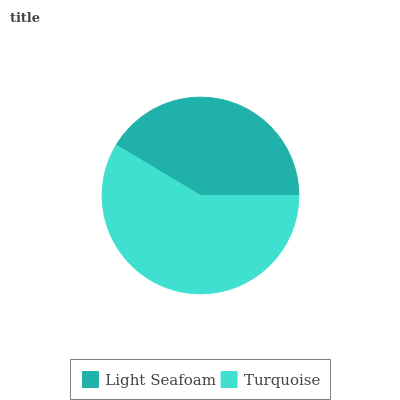Is Light Seafoam the minimum?
Answer yes or no. Yes. Is Turquoise the maximum?
Answer yes or no. Yes. Is Turquoise the minimum?
Answer yes or no. No. Is Turquoise greater than Light Seafoam?
Answer yes or no. Yes. Is Light Seafoam less than Turquoise?
Answer yes or no. Yes. Is Light Seafoam greater than Turquoise?
Answer yes or no. No. Is Turquoise less than Light Seafoam?
Answer yes or no. No. Is Turquoise the high median?
Answer yes or no. Yes. Is Light Seafoam the low median?
Answer yes or no. Yes. Is Light Seafoam the high median?
Answer yes or no. No. Is Turquoise the low median?
Answer yes or no. No. 